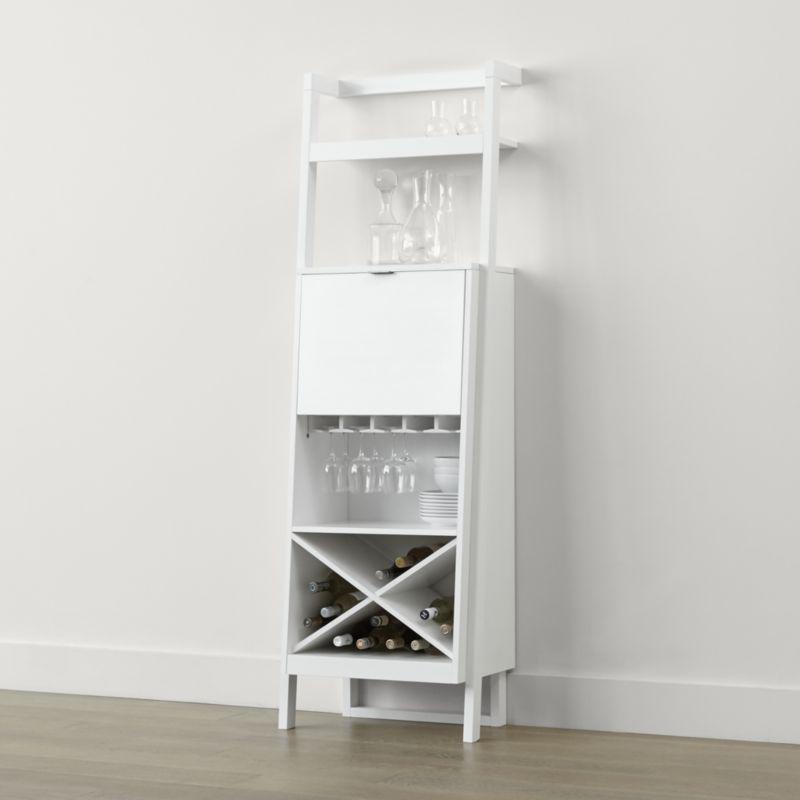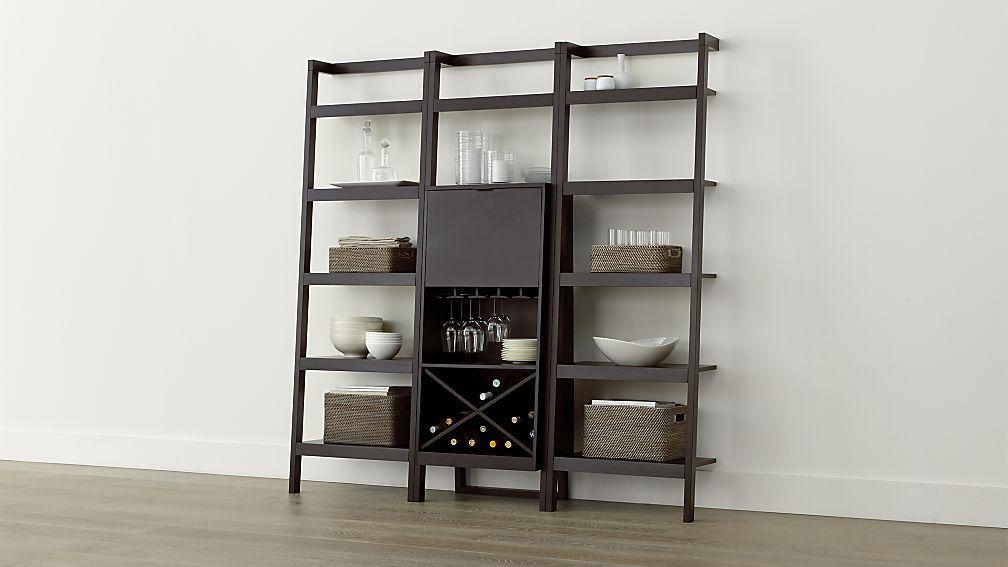The first image is the image on the left, the second image is the image on the right. Considering the images on both sides, is "The shelf in the image on the left is white, while the shelf on the right is darker." valid? Answer yes or no. Yes. The first image is the image on the left, the second image is the image on the right. Evaluate the accuracy of this statement regarding the images: "An image shows a dark storage unit with rows of shelves flanking an X-shaped compartment that holds wine bottles.". Is it true? Answer yes or no. Yes. 